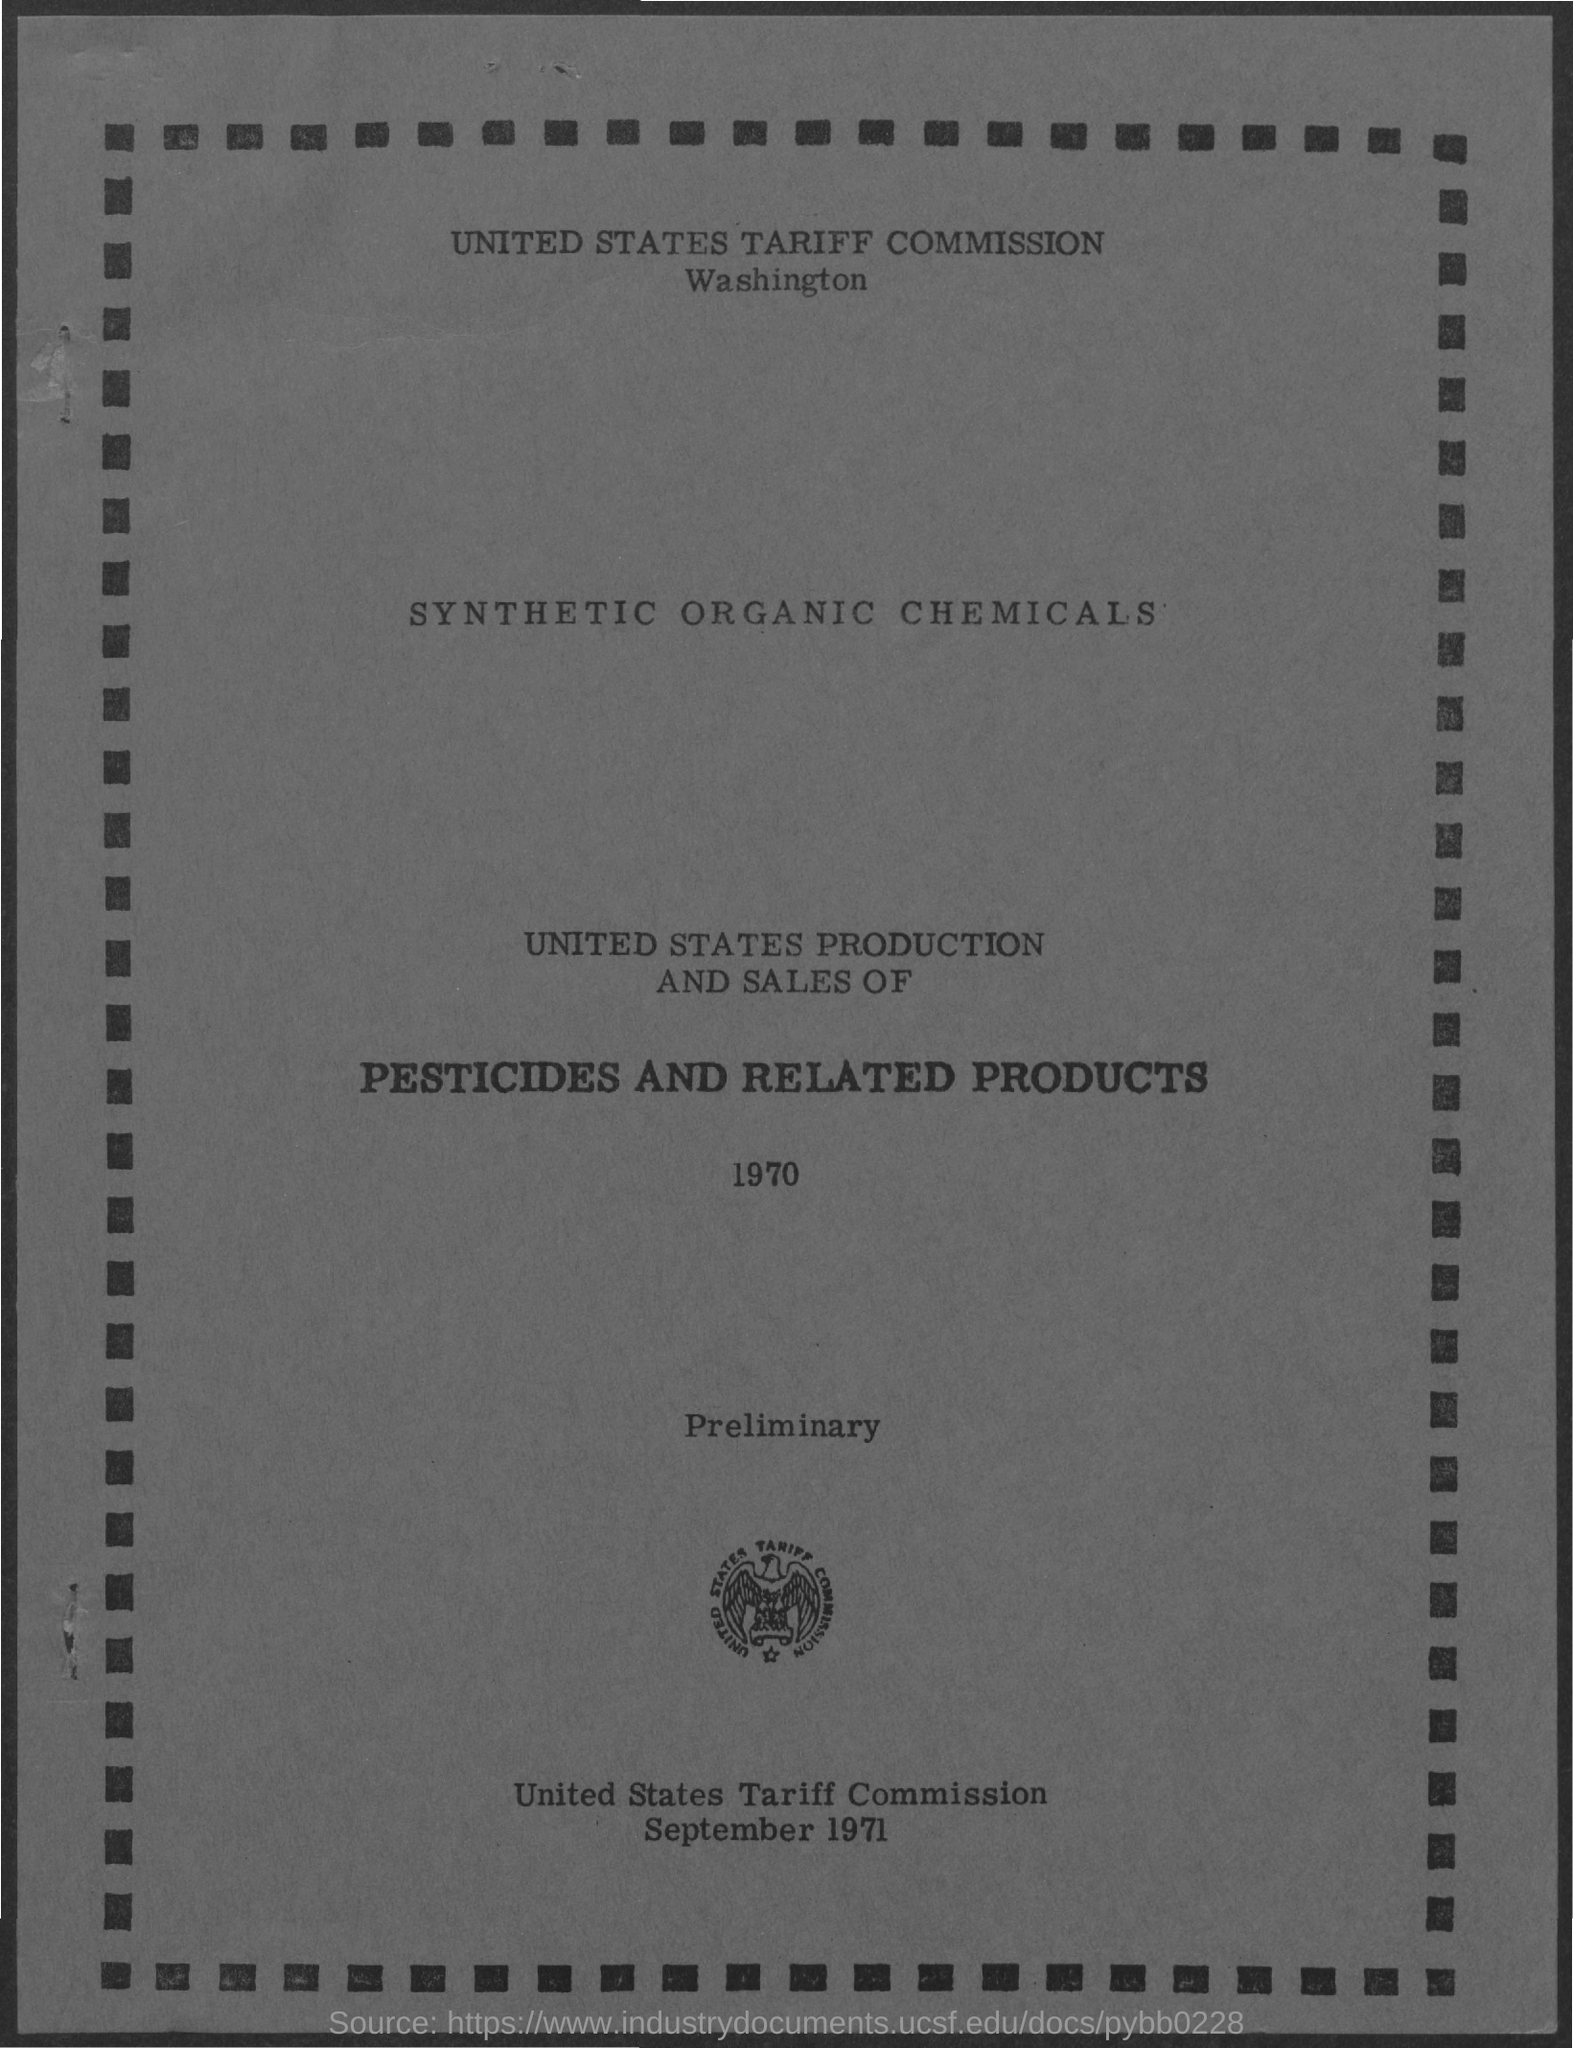Mention a couple of crucial points in this snapshot. The document's first title is "United States Tariff Commission. 